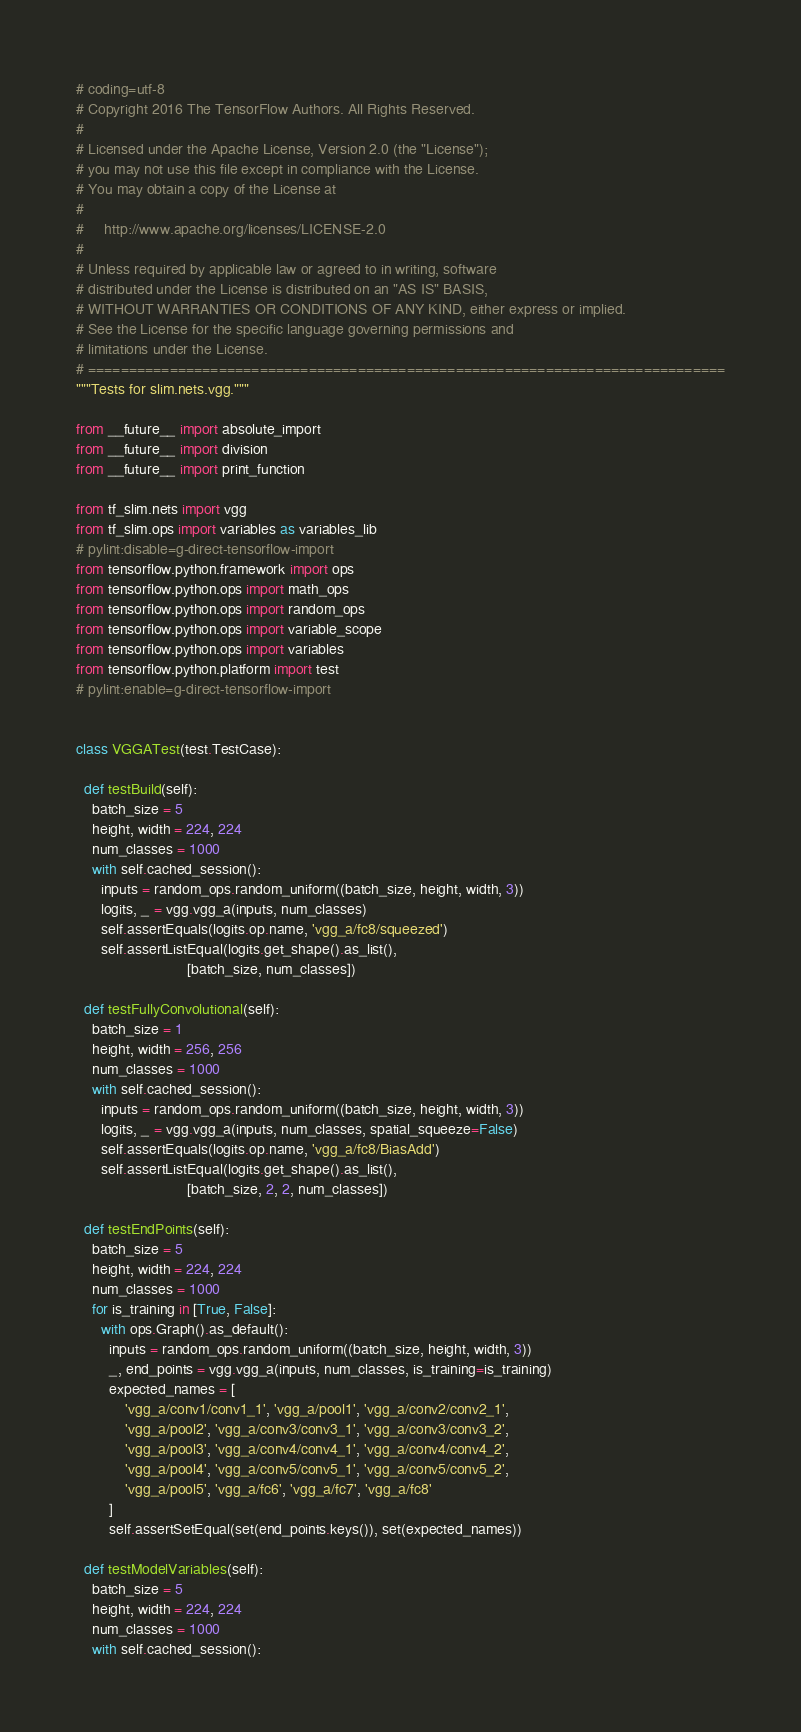Convert code to text. <code><loc_0><loc_0><loc_500><loc_500><_Python_># coding=utf-8
# Copyright 2016 The TensorFlow Authors. All Rights Reserved.
#
# Licensed under the Apache License, Version 2.0 (the "License");
# you may not use this file except in compliance with the License.
# You may obtain a copy of the License at
#
#     http://www.apache.org/licenses/LICENSE-2.0
#
# Unless required by applicable law or agreed to in writing, software
# distributed under the License is distributed on an "AS IS" BASIS,
# WITHOUT WARRANTIES OR CONDITIONS OF ANY KIND, either express or implied.
# See the License for the specific language governing permissions and
# limitations under the License.
# ==============================================================================
"""Tests for slim.nets.vgg."""

from __future__ import absolute_import
from __future__ import division
from __future__ import print_function

from tf_slim.nets import vgg
from tf_slim.ops import variables as variables_lib
# pylint:disable=g-direct-tensorflow-import
from tensorflow.python.framework import ops
from tensorflow.python.ops import math_ops
from tensorflow.python.ops import random_ops
from tensorflow.python.ops import variable_scope
from tensorflow.python.ops import variables
from tensorflow.python.platform import test
# pylint:enable=g-direct-tensorflow-import


class VGGATest(test.TestCase):

  def testBuild(self):
    batch_size = 5
    height, width = 224, 224
    num_classes = 1000
    with self.cached_session():
      inputs = random_ops.random_uniform((batch_size, height, width, 3))
      logits, _ = vgg.vgg_a(inputs, num_classes)
      self.assertEquals(logits.op.name, 'vgg_a/fc8/squeezed')
      self.assertListEqual(logits.get_shape().as_list(),
                           [batch_size, num_classes])

  def testFullyConvolutional(self):
    batch_size = 1
    height, width = 256, 256
    num_classes = 1000
    with self.cached_session():
      inputs = random_ops.random_uniform((batch_size, height, width, 3))
      logits, _ = vgg.vgg_a(inputs, num_classes, spatial_squeeze=False)
      self.assertEquals(logits.op.name, 'vgg_a/fc8/BiasAdd')
      self.assertListEqual(logits.get_shape().as_list(),
                           [batch_size, 2, 2, num_classes])

  def testEndPoints(self):
    batch_size = 5
    height, width = 224, 224
    num_classes = 1000
    for is_training in [True, False]:
      with ops.Graph().as_default():
        inputs = random_ops.random_uniform((batch_size, height, width, 3))
        _, end_points = vgg.vgg_a(inputs, num_classes, is_training=is_training)
        expected_names = [
            'vgg_a/conv1/conv1_1', 'vgg_a/pool1', 'vgg_a/conv2/conv2_1',
            'vgg_a/pool2', 'vgg_a/conv3/conv3_1', 'vgg_a/conv3/conv3_2',
            'vgg_a/pool3', 'vgg_a/conv4/conv4_1', 'vgg_a/conv4/conv4_2',
            'vgg_a/pool4', 'vgg_a/conv5/conv5_1', 'vgg_a/conv5/conv5_2',
            'vgg_a/pool5', 'vgg_a/fc6', 'vgg_a/fc7', 'vgg_a/fc8'
        ]
        self.assertSetEqual(set(end_points.keys()), set(expected_names))

  def testModelVariables(self):
    batch_size = 5
    height, width = 224, 224
    num_classes = 1000
    with self.cached_session():</code> 